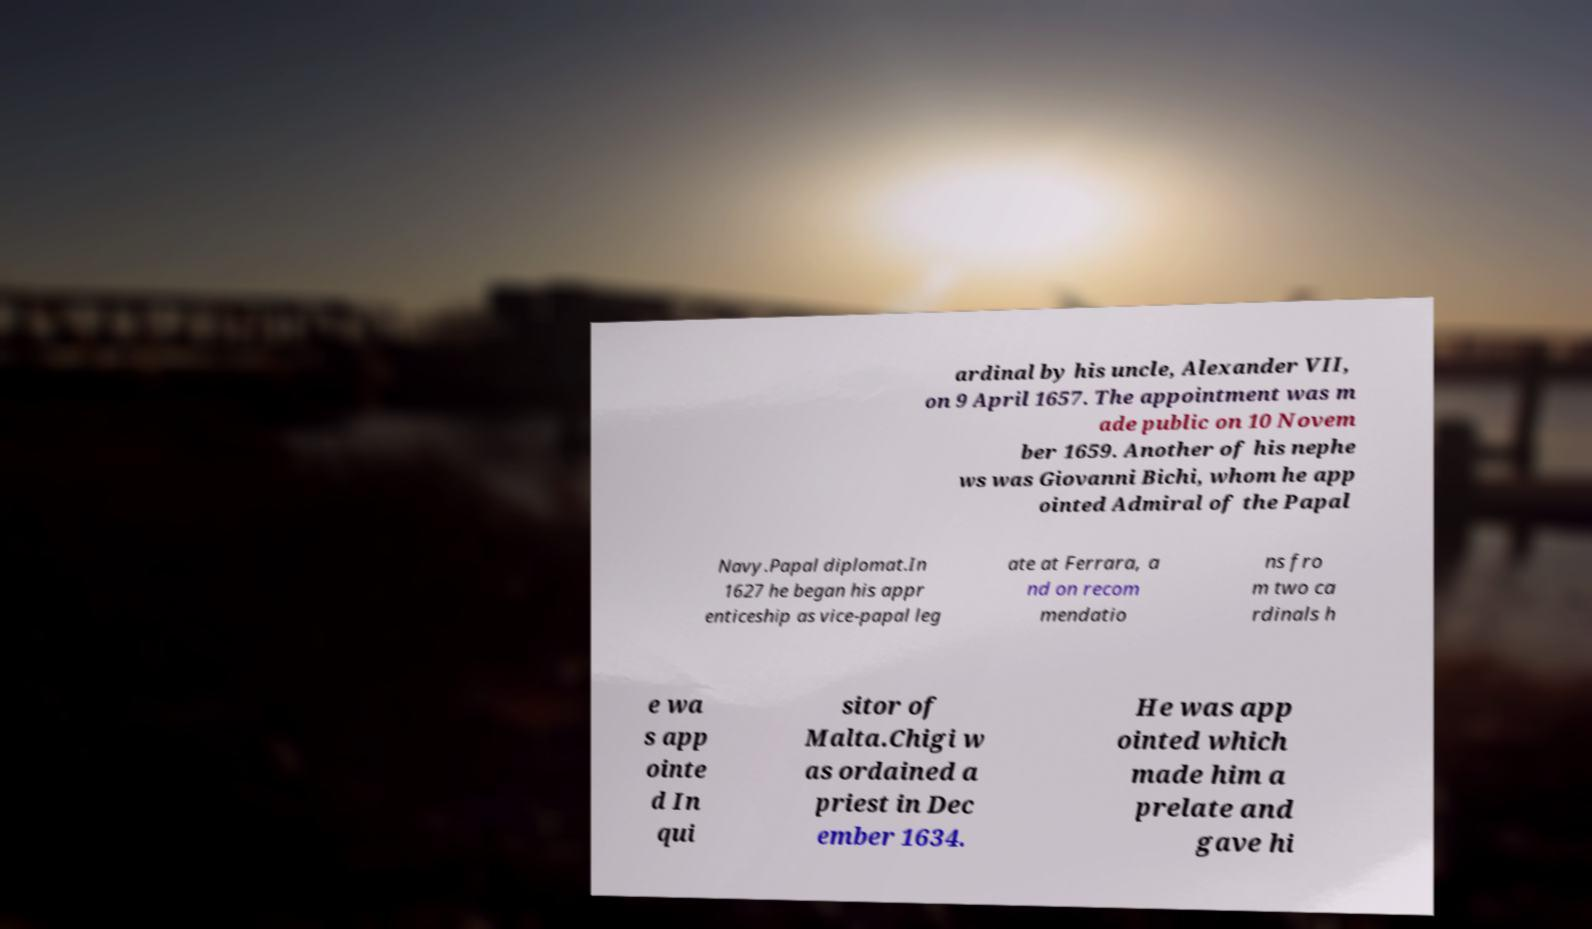There's text embedded in this image that I need extracted. Can you transcribe it verbatim? ardinal by his uncle, Alexander VII, on 9 April 1657. The appointment was m ade public on 10 Novem ber 1659. Another of his nephe ws was Giovanni Bichi, whom he app ointed Admiral of the Papal Navy.Papal diplomat.In 1627 he began his appr enticeship as vice-papal leg ate at Ferrara, a nd on recom mendatio ns fro m two ca rdinals h e wa s app ointe d In qui sitor of Malta.Chigi w as ordained a priest in Dec ember 1634. He was app ointed which made him a prelate and gave hi 